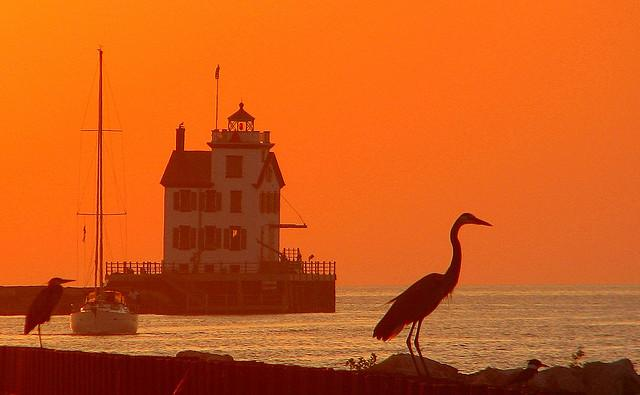What are the birds in front of? water 